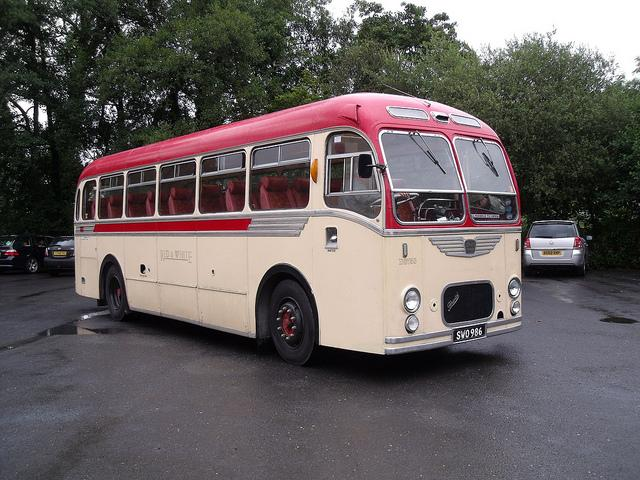What is the purpose of this vehicle?

Choices:
A) school bus
B) speed
C) carry cargo
D) carry passengers carry passengers 